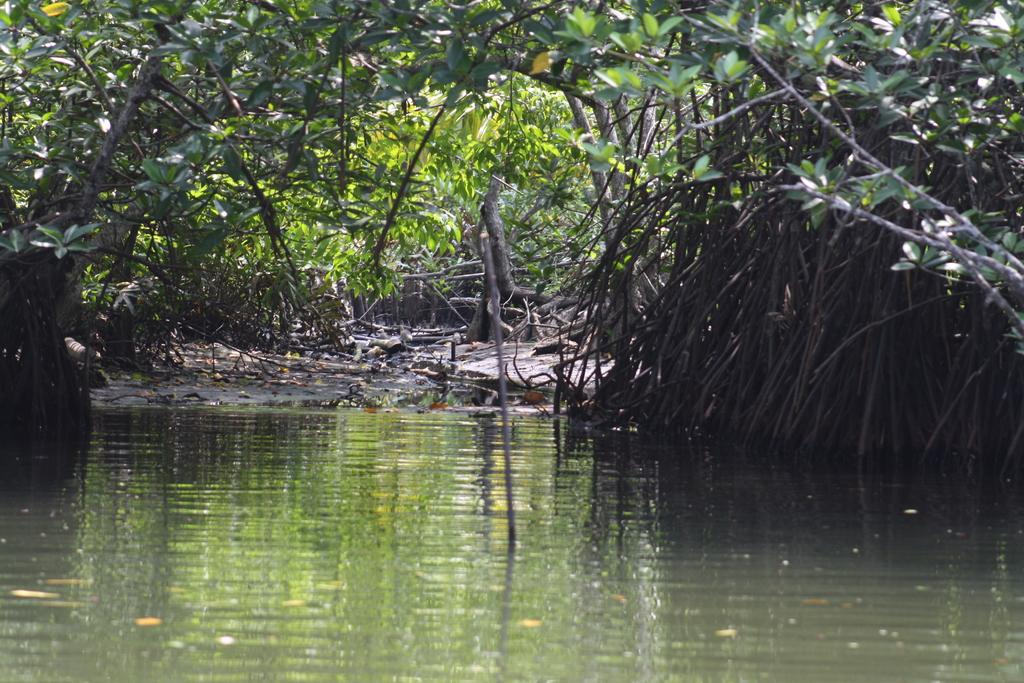What type of trees are visible in the image? There are trees with branches and leaves in the image. What is happening with the water in the image? There is water flowing in the image. What type of whip can be seen in the image? There is no whip present in the image. What do the trees believe about the water in the image? Trees do not have beliefs, as they are inanimate objects. 